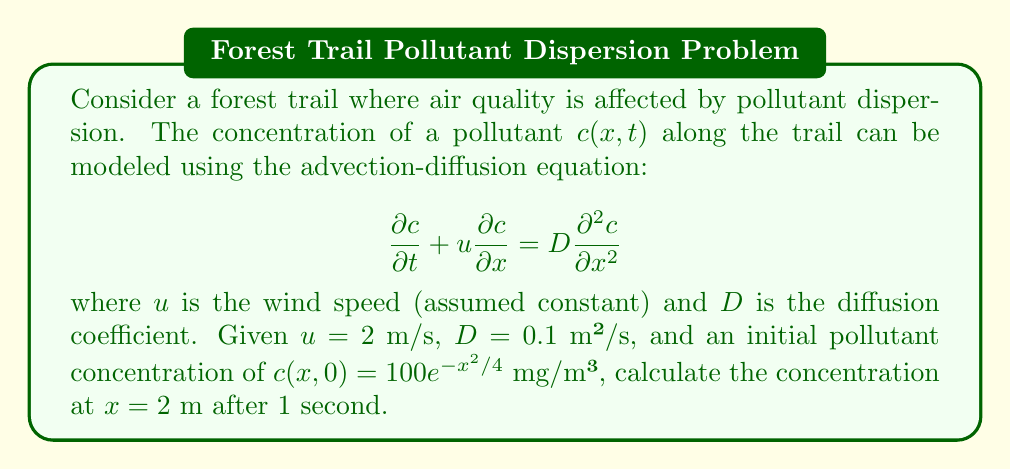Can you answer this question? To solve this problem, we'll use the analytical solution for the advection-diffusion equation with an initial Gaussian distribution. The solution is given by:

$$c(x,t) = \frac{M}{\sqrt{4\pi Dt}} \exp\left(-\frac{(x-ut)^2}{4Dt}\right)$$

where $M$ is the total mass of the pollutant per unit cross-sectional area.

Steps to solve:

1. Identify the initial distribution parameters:
   The initial concentration is given as $c(x,0) = 100e^{-x^2/4}$ mg/m³.
   Comparing this to the standard form of a Gaussian distribution:
   $$f(x) = \frac{1}{\sigma\sqrt{2\pi}} e^{-\frac{(x-\mu)^2}{2\sigma^2}}$$
   We can see that $\sigma^2 = 2$ and the peak concentration is 100 mg/m³.

2. Calculate the total mass $M$:
   $$M = 100 \cdot \sigma\sqrt{2\pi} = 100 \cdot \sqrt{4\pi} \approx 354.49$$

3. Use the analytical solution with the given parameters:
   $x = 2$ m, $t = 1$ s, $u = 2$ m/s, $D = 0.1$ m²/s

   $$c(2,1) = \frac{354.49}{\sqrt{4\pi \cdot 0.1 \cdot 1}} \exp\left(-\frac{(2-2\cdot1)^2}{4\cdot0.1\cdot1}\right)$$

4. Simplify and calculate:
   $$c(2,1) = \frac{354.49}{\sqrt{0.4\pi}} \exp\left(-\frac{0^2}{0.4}\right) = \frac{354.49}{\sqrt{0.4\pi}} \cdot 1$$

5. Evaluate the final result:
   $$c(2,1) \approx 315.47$$ mg/m³
Answer: The concentration of the pollutant at $x = 2$ m after 1 second is approximately 315.47 mg/m³. 